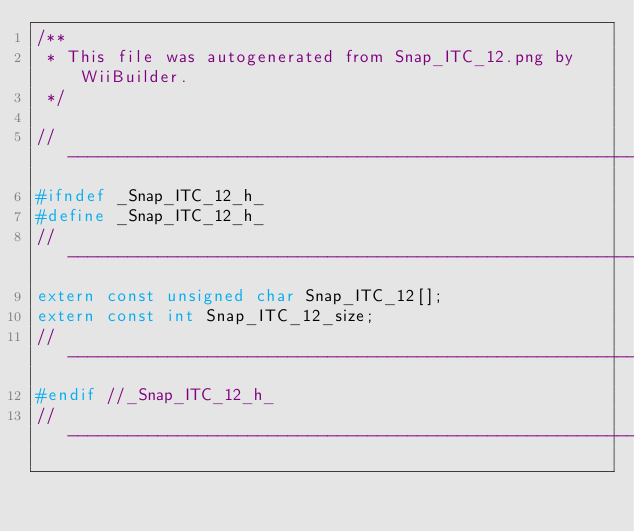Convert code to text. <code><loc_0><loc_0><loc_500><loc_500><_C_>/**
 * This file was autogenerated from Snap_ITC_12.png by WiiBuilder.
 */

//---------------------------------------------------------------------------------
#ifndef _Snap_ITC_12_h_
#define _Snap_ITC_12_h_
//---------------------------------------------------------------------------------
extern const unsigned char Snap_ITC_12[];
extern const int Snap_ITC_12_size;
//---------------------------------------------------------------------------------
#endif //_Snap_ITC_12_h_
//---------------------------------------------------------------------------------
</code> 